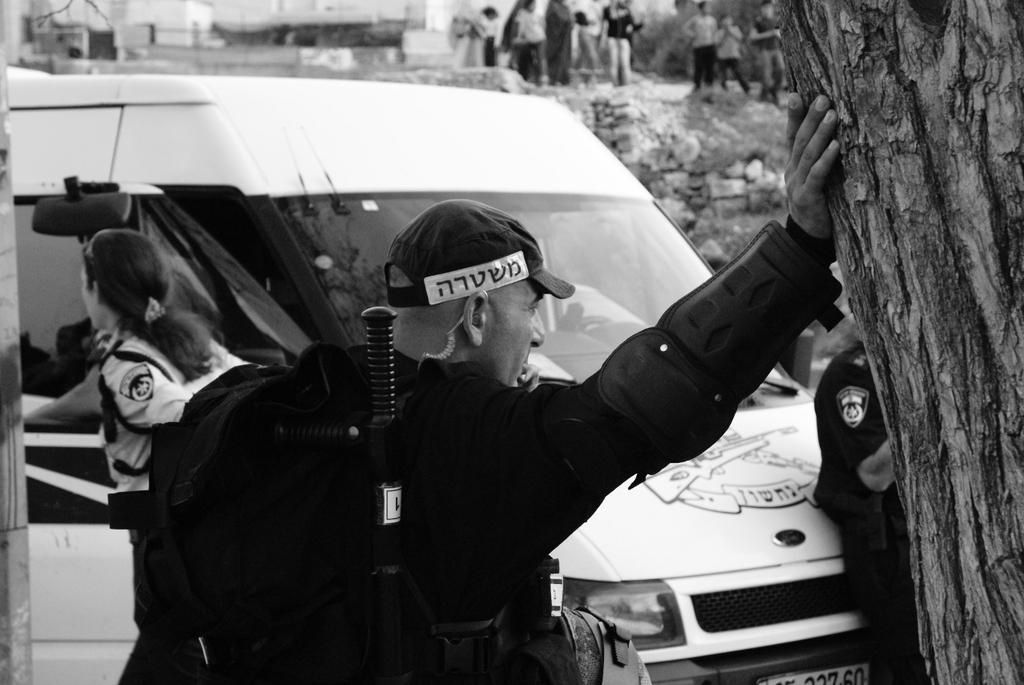What is the color scheme of the image? The image is black and white. What can be seen in the image? There are people, a vehicle, rocks, and a branch in the image. What type of objects are present in the image? There are objects in the image, but their specific nature is not mentioned in the facts. How is the background of the image? The background of the image is blurry. Are there any other people visible in the image? Yes, there are people in the background of the image. What type of fuel is being used by the people in the image? There is no information about fuel usage in the image, as it is a black and white image with people, a vehicle, rocks, and a branch. What feelings are being expressed by the people in the image? The image is black and white, and there is no information about the feelings or expressions of the people in the image. 